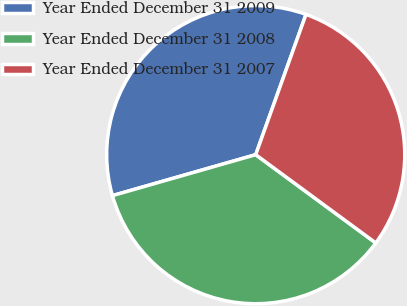Convert chart. <chart><loc_0><loc_0><loc_500><loc_500><pie_chart><fcel>Year Ended December 31 2009<fcel>Year Ended December 31 2008<fcel>Year Ended December 31 2007<nl><fcel>34.91%<fcel>35.48%<fcel>29.61%<nl></chart> 